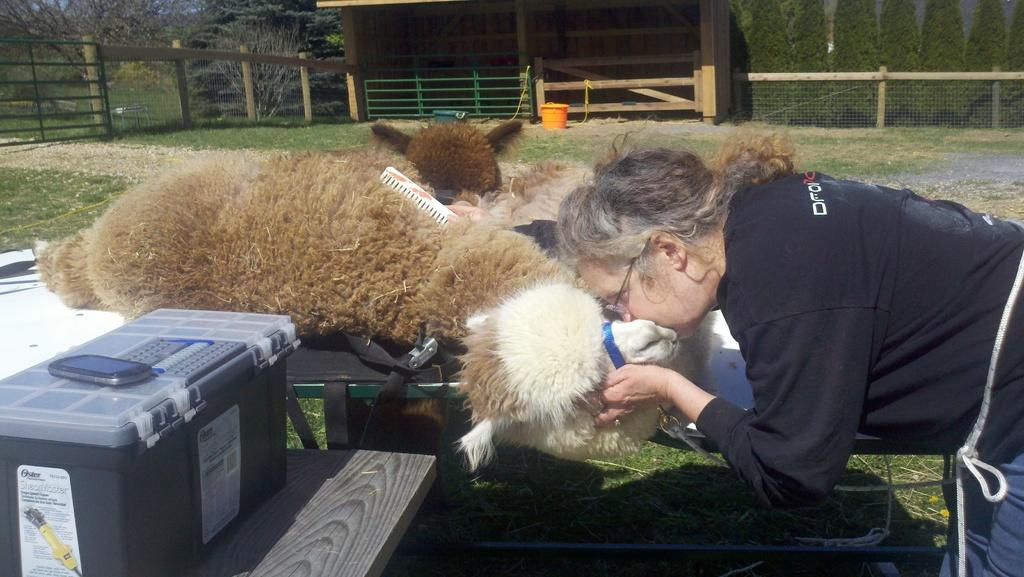What is on the table in the image? There are animals on the table in the image. What is the person in the image doing with one of the animals? The person is holding one of the animals. What can be seen in the background of the image? There is a shed, mesh, trees, and the ground visible in the background of the image. Can you describe the object on which the mobile phone is placed in the background? The mobile phone is on a plastic container in the background of the image. How does the baby react to the earthquake in the image? There is no baby or earthquake present in the image. What type of visitor can be seen interacting with the animals in the image? There is no visitor present in the image; only a person holding one of the animals is visible. 